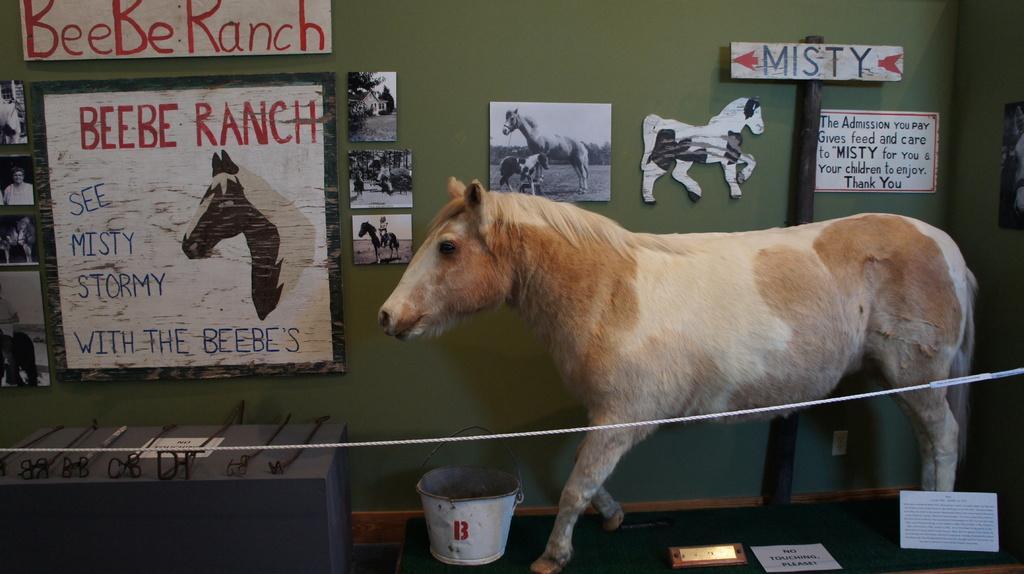In one or two sentences, can you explain what this image depicts? In the background we can see the frames, boards on the wall and a pole. On a table we can see the black objects and a paper note. In this picture we can see an animal. It seems like a depiction of an animal. We can see a bucket, an object and we can see some information on the papers. 